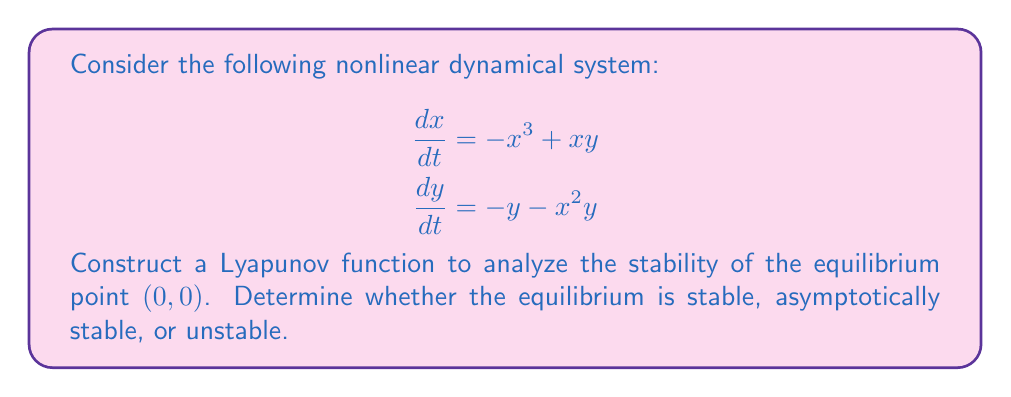Provide a solution to this math problem. 1) First, let's construct a candidate Lyapunov function. Given the structure of the system, a suitable choice might be:

   $$V(x,y) = \frac{1}{2}(x^2 + y^2)$$

2) Now, we need to check if $V(x,y)$ satisfies the conditions for a Lyapunov function:
   
   a) $V(0,0) = 0$
   b) $V(x,y) > 0$ for all $(x,y) \neq (0,0)$
   
   Both conditions are clearly satisfied.

3) Next, we need to calculate $\frac{dV}{dt}$ along the trajectories of the system:

   $$\begin{aligned}
   \frac{dV}{dt} &= \frac{\partial V}{\partial x}\frac{dx}{dt} + \frac{\partial V}{\partial y}\frac{dy}{dt} \\
   &= x(-x^3+xy) + y(-y-x^2y) \\
   &= -x^4 + x^2y - y^2 - x^2y^2 \\
   &= -(x^4 + y^2) - x^2y^2 + x^2y
   \end{aligned}$$

4) To determine stability, we need to analyze the sign of $\frac{dV}{dt}$:

   $-(x^4 + y^2)$ is always non-positive.
   $-x^2y^2$ is always non-positive.
   $x^2y$ could be positive or negative.

5) We can complete the square for the $y$ terms:

   $$\frac{dV}{dt} = -(x^4 + y^2) - x^2(y^2 - y + \frac{1}{4}) + \frac{1}{4}x^2$$
   $$= -(x^4 + y^2) - x^2(y - \frac{1}{2})^2 + \frac{1}{4}x^2$$

6) Now we can see that $\frac{dV}{dt} < 0$ for all $(x,y) \neq (0,0)$ in a neighborhood of $(0,0)$, except when $x=0$ and $y=0$, where it equals zero.

7) Since $V(x,y)$ is positive definite and $\frac{dV}{dt}$ is negative definite in a neighborhood of $(0,0)$, we can conclude that the equilibrium point $(0,0)$ is asymptotically stable.
Answer: The equilibrium point $(0,0)$ is asymptotically stable. 